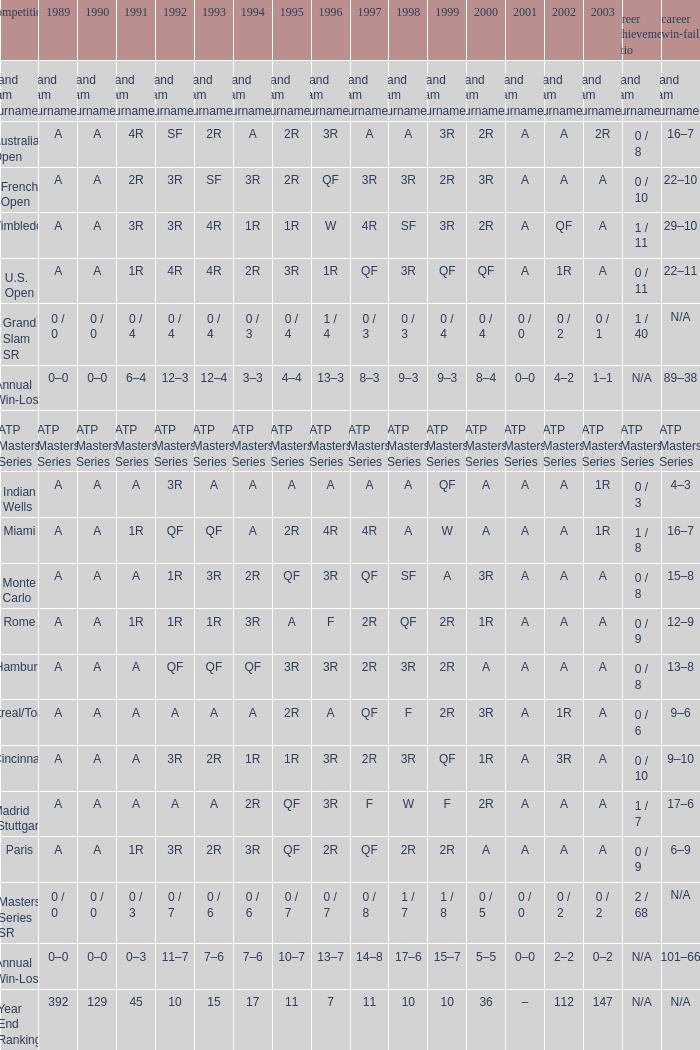What was the 1997 value when 2002 was A and 2003 was 1R? A, 4R. 